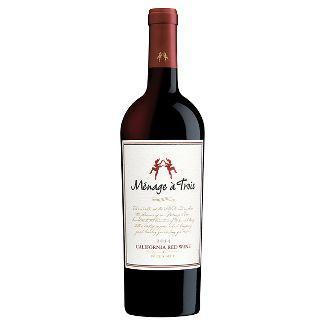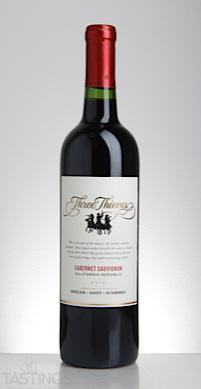The first image is the image on the left, the second image is the image on the right. Evaluate the accuracy of this statement regarding the images: "The combined images include at least two wine bottles with white-background labels.". Is it true? Answer yes or no. Yes. The first image is the image on the left, the second image is the image on the right. Considering the images on both sides, is "The label of the bottle of red wine has the words Three Thieves in gold writing." valid? Answer yes or no. Yes. 